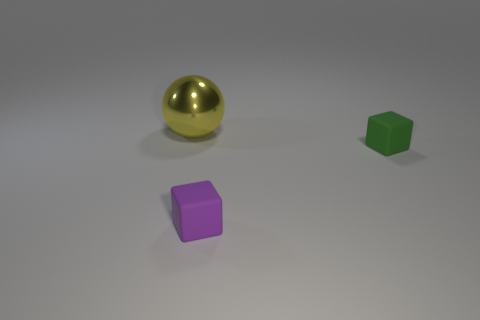What is the big yellow sphere made of?
Provide a short and direct response. Metal. Does the tiny green object have the same shape as the tiny purple thing?
Keep it short and to the point. Yes. There is a object behind the cube behind the matte block that is on the left side of the small green matte thing; what is its size?
Provide a succinct answer. Large. How many other objects are there of the same material as the purple cube?
Provide a succinct answer. 1. The tiny matte object to the right of the purple matte cube is what color?
Provide a short and direct response. Green. There is a object that is on the right side of the small object in front of the tiny rubber cube that is behind the purple matte object; what is it made of?
Your answer should be compact. Rubber. Are there any purple matte things that have the same shape as the small green object?
Keep it short and to the point. Yes. There is another matte object that is the same size as the purple matte object; what is its shape?
Offer a terse response. Cube. How many things are behind the purple matte thing and in front of the large yellow ball?
Offer a very short reply. 1. Is the number of small blocks that are on the right side of the big yellow thing less than the number of objects?
Your answer should be very brief. Yes. 